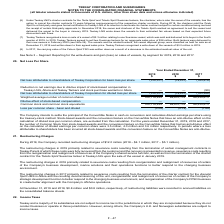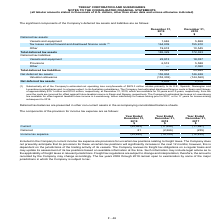According to Teekay Corporation's financial document, What is the Net deferred tax assets in 2019? According to the financial document, 2,602 (in thousands). The relevant text states: "Net deferred tax assets 2,602 2,078..." Also, How much is the estimated disallowed finance costs in Spain and Norway at December 31, 2019 respectively? The document shows two values: $15.1 million and $15.0 million. From the document: "pain and Norway of approximately $15.1 million and $15.0 million, respectively, at December 31, 2019, which are available for 18 years and 10 years, r..." Also, Which subsidiaries are subject to income taxes? the Company’s U.K. and Norwegian subsidiaries are subject to income taxes.. The document states: "ate in those jurisdictions. However, among others, the Company’s U.K. and Norwegian subsidiaries are subject to income taxes...." Also, can you calculate: What is the change in Deferred tax assets: Vessels and equipment from December 31, 2019 to December 31, 2018? Based on the calculation: 1,646-5,868, the result is -4222 (in thousands). This is based on the information: "Vessels and equipment 1,646 5,868 Vessels and equipment 1,646 5,868..." The key data points involved are: 1,646, 5,868. Also, can you calculate: What is the change in Deferred tax assets: Tax losses carried forward and disallowed finance costs from December 31, 2019 to December 31, 2018? Based on the calculation: 164,009-155,910, the result is 8099 (in thousands). This is based on the information: "carried forward and disallowed finance costs (1) 164,009 155,910 forward and disallowed finance costs (1) 164,009 155,910..." The key data points involved are: 155,910, 164,009. Also, can you calculate: What is the change in Deferred tax assets: Other from December 31, 2019 to December 31, 2018? Based on the calculation: 19,674-10,545, the result is 9129 (in thousands). This is based on the information: "Other 19,674 10,545 Other 19,674 10,545..." The key data points involved are: 10,545, 19,674. 